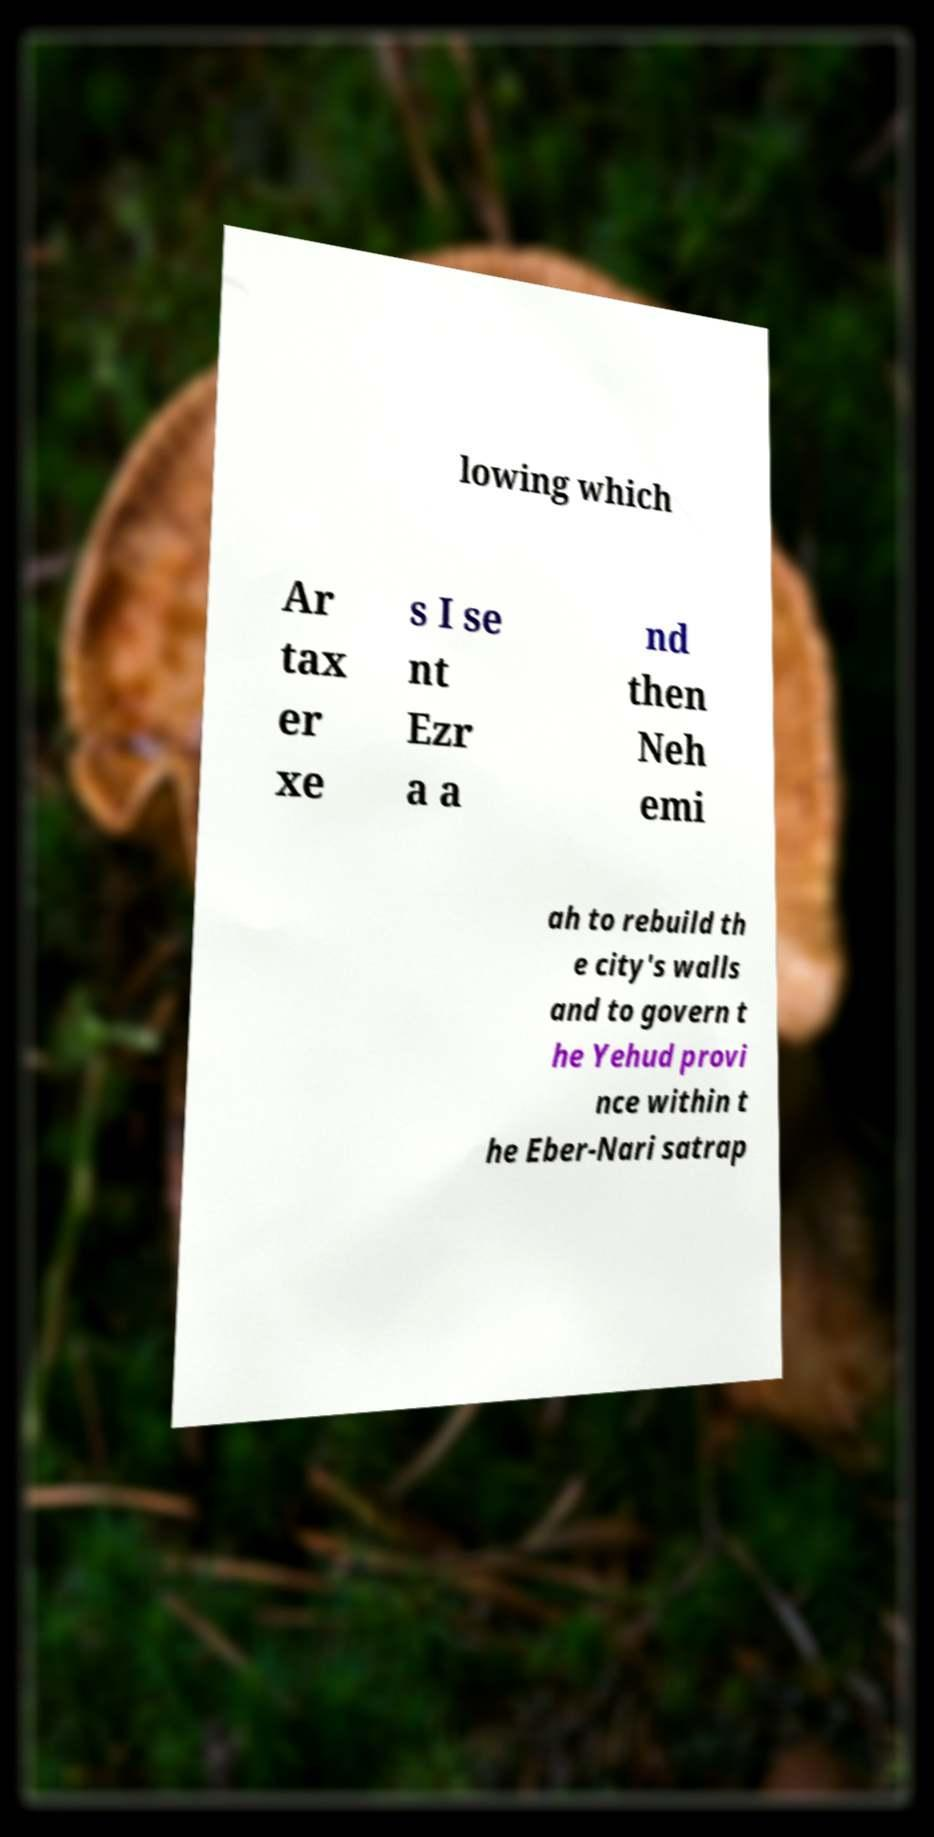Could you assist in decoding the text presented in this image and type it out clearly? lowing which Ar tax er xe s I se nt Ezr a a nd then Neh emi ah to rebuild th e city's walls and to govern t he Yehud provi nce within t he Eber-Nari satrap 